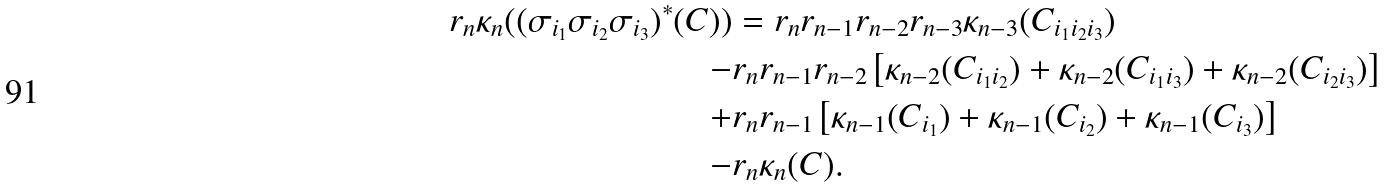Convert formula to latex. <formula><loc_0><loc_0><loc_500><loc_500>r _ { n } \kappa _ { n } ( ( \sigma _ { i _ { 1 } } \sigma _ { i _ { 2 } } \sigma _ { i _ { 3 } } ) ^ { * } ( C ) ) & = r _ { n } r _ { n - 1 } r _ { n - 2 } r _ { n - 3 } \kappa _ { n - 3 } ( C _ { i _ { 1 } i _ { 2 } i _ { 3 } } ) \\ - & r _ { n } r _ { n - 1 } r _ { n - 2 } \left [ \kappa _ { n - 2 } ( C _ { i _ { 1 } i _ { 2 } } ) + \kappa _ { n - 2 } ( C _ { i _ { 1 } i _ { 3 } } ) + \kappa _ { n - 2 } ( C _ { i _ { 2 } i _ { 3 } } ) \right ] \\ + & r _ { n } r _ { n - 1 } \left [ \kappa _ { n - 1 } ( C _ { i _ { 1 } } ) + \kappa _ { n - 1 } ( C _ { i _ { 2 } } ) + \kappa _ { n - 1 } ( C _ { i _ { 3 } } ) \right ] \\ - & r _ { n } \kappa _ { n } ( C ) .</formula> 